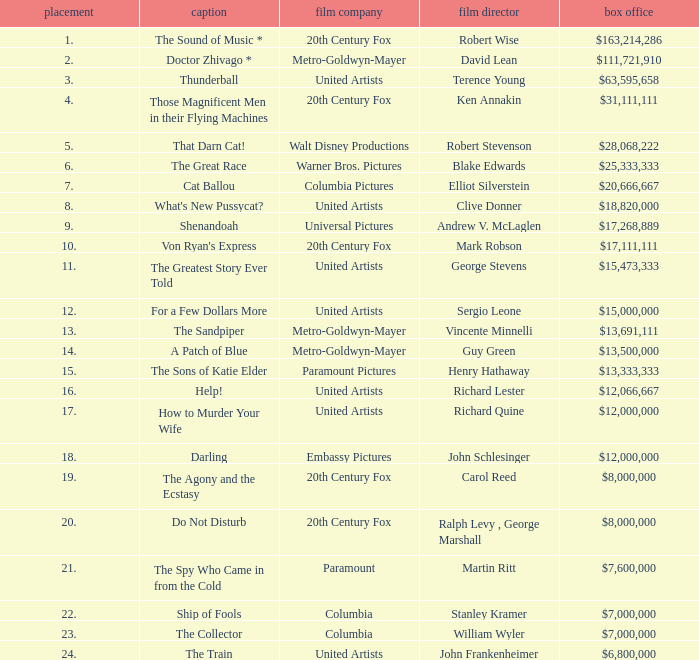What is Studio, when Title is "Do Not Disturb"? 20th Century Fox. 